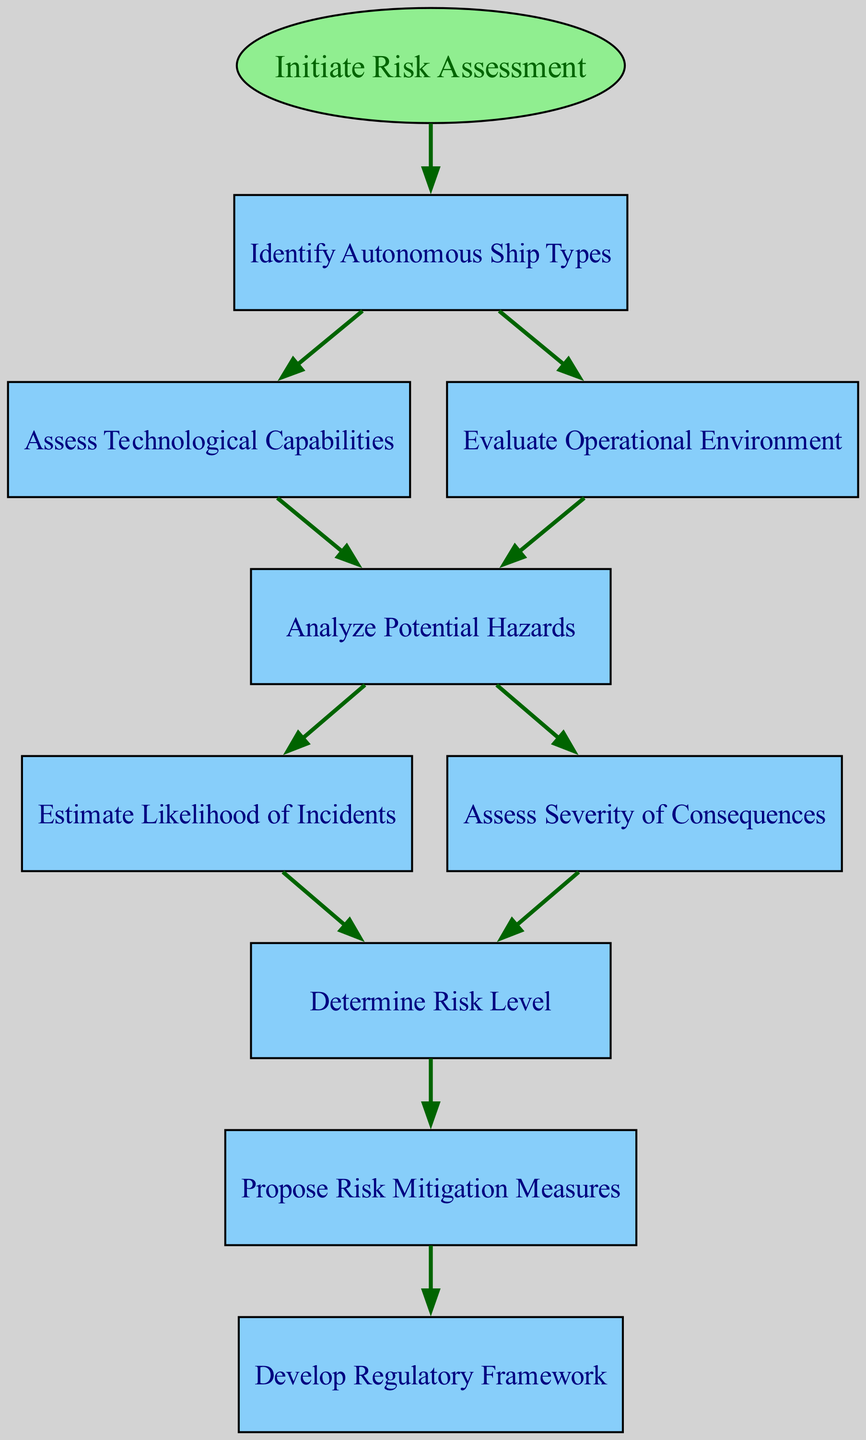What is the starting point of the risk assessment? The diagram clearly indicates that the risk assessment begins with the node labeled "Initiate Risk Assessment," which is the first step linked to the start node.
Answer: Initiate Risk Assessment How many nodes are present in the diagram? By counting each individual box in the diagram and including the start node, we find there are a total of 9 nodes that represent different steps in the risk assessment framework.
Answer: 9 What is the next step after identifying autonomous ship types? According to the flow of the diagram, after "Identify Autonomous Ship Types," the next possible steps are "Assess Technological Capabilities" or "Evaluate Operational Environment."
Answer: Assess Technological Capabilities, Evaluate Operational Environment What two analyses are conducted after analyzing potential hazards? After the "Analyze Potential Hazards" node, the diagram shows the next steps are "Estimate Likelihood of Incidents" and "Assess Severity of Consequences," indicating both analyses are critical after identifying hazards.
Answer: Estimate Likelihood of Incidents, Assess Severity of Consequences What node connects to the "Determine Risk Level"? The diagram specifies that "Estimate Likelihood of Incidents" and "Assess Severity of Consequences" lead to the "Determine Risk Level" node, indicating the assessment of both factors is required to determine the risk.
Answer: Analyze Potential Hazards What is the final step in the risk assessment framework? The last node in the diagram is "Develop Regulatory Framework," confirming that it is the concluding action after risk mitigation measures have been proposed.
Answer: Develop Regulatory Framework Which node is assessed based on technological capabilities? The flow chart indicates that after identifying autonomous ship types, the direct assessment related to technological evaluation is captured by the "Assess Technological Capabilities" node.
Answer: Assess Technological Capabilities What is the connection between assessing severity and determining risk level? The diagram illustrates that both "Assess Severity of Consequences" and "Estimate Likelihood of Incidents" are prerequisites to "Determine Risk Level," showing they are crucial interconnected steps for this process.
Answer: Risk assessment dependency 